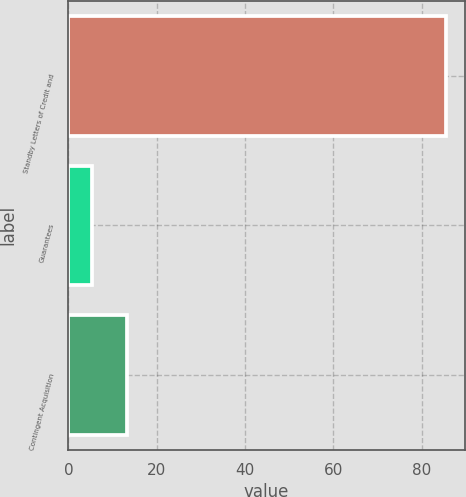Convert chart. <chart><loc_0><loc_0><loc_500><loc_500><bar_chart><fcel>Standby Letters of Credit and<fcel>Guarantees<fcel>Contingent Acquisition<nl><fcel>85.5<fcel>5.3<fcel>13.32<nl></chart> 